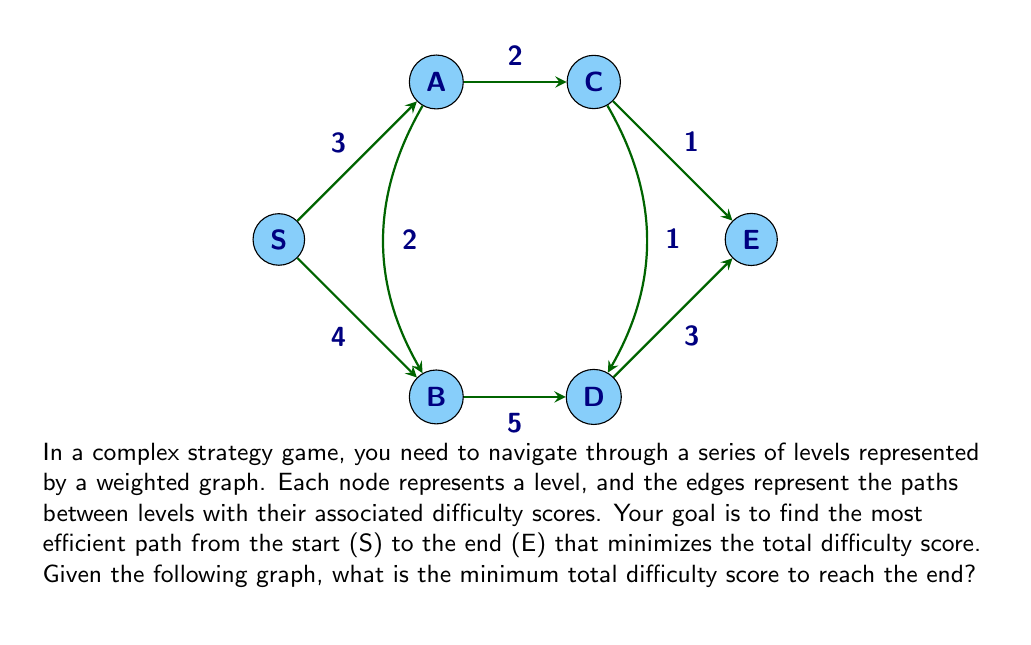Solve this math problem. To solve this problem, we need to consider all possible paths from S to E and calculate their total difficulty scores. Then, we'll choose the path with the minimum score.

Possible paths:
1. S → A → C → E
2. S → A → B → D → E
3. S → A → C → D → E
4. S → B → A → C → E
5. S → B → D → E
6. S → B → D → C → E

Let's calculate the difficulty score for each path:

1. S → A → C → E
   $$ 3 + 2 + 1 = 6 $$

2. S → A → B → D → E
   $$ 3 + 2 + 5 + 3 = 13 $$

3. S → A → C → D → E
   $$ 3 + 2 + 1 + 3 = 9 $$

4. S → B → A → C → E
   $$ 4 + 2 + 2 + 1 = 9 $$

5. S → B → D → E
   $$ 4 + 5 + 3 = 12 $$

6. S → B → D → C → E
   $$ 4 + 5 + 1 + 1 = 11 $$

The path with the minimum difficulty score is S → A → C → E, with a total score of 6.
Answer: The minimum total difficulty score to reach the end is 6. 